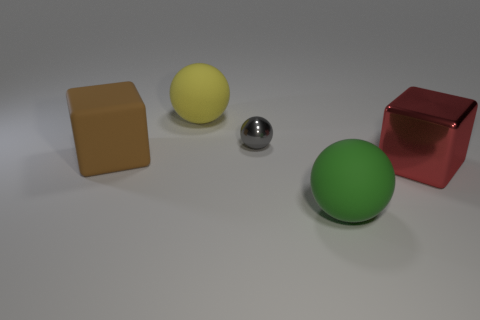Add 4 large gray metal balls. How many objects exist? 9 Subtract all spheres. How many objects are left? 2 Add 1 big blue shiny blocks. How many big blue shiny blocks exist? 1 Subtract 0 blue spheres. How many objects are left? 5 Subtract all small gray spheres. Subtract all green things. How many objects are left? 3 Add 1 big green things. How many big green things are left? 2 